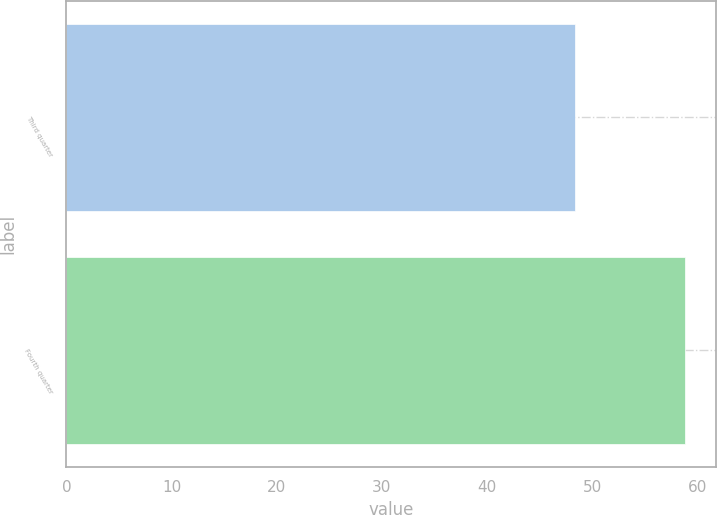<chart> <loc_0><loc_0><loc_500><loc_500><bar_chart><fcel>Third quarter<fcel>Fourth quarter<nl><fcel>48.34<fcel>58.84<nl></chart> 